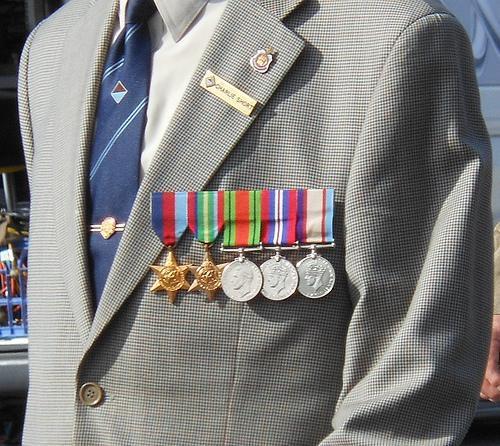How many medals on the man's jacket?
Give a very brief answer. 5. How many medals have six points??
Give a very brief answer. 2. 